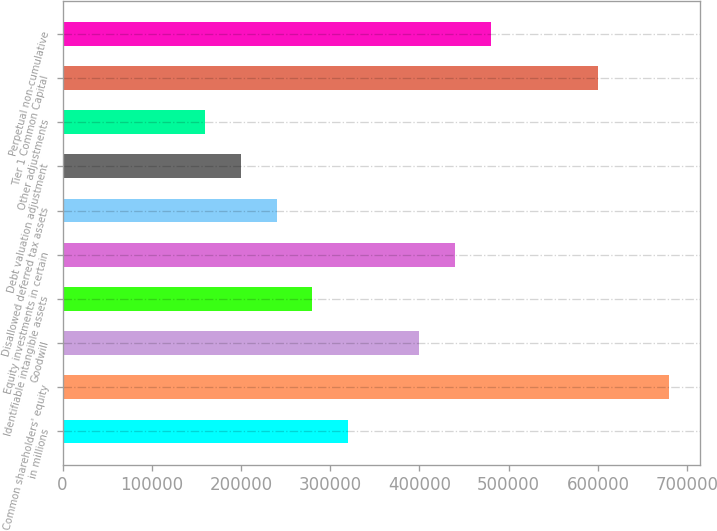Convert chart to OTSL. <chart><loc_0><loc_0><loc_500><loc_500><bar_chart><fcel>in millions<fcel>Common shareholders' equity<fcel>Goodwill<fcel>Identifiable intangible assets<fcel>Equity investments in certain<fcel>Disallowed deferred tax assets<fcel>Debt valuation adjustment<fcel>Other adjustments<fcel>Tier 1 Common Capital<fcel>Perpetual non-cumulative<nl><fcel>319944<fcel>679872<fcel>399928<fcel>279952<fcel>439920<fcel>239960<fcel>199968<fcel>159976<fcel>599888<fcel>479912<nl></chart> 